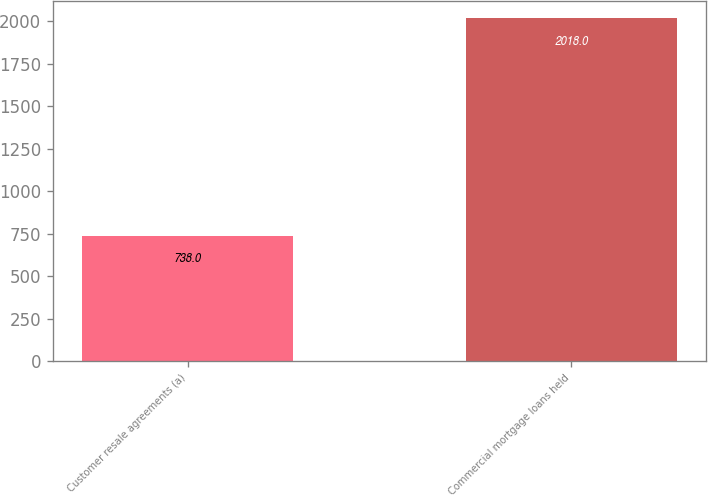<chart> <loc_0><loc_0><loc_500><loc_500><bar_chart><fcel>Customer resale agreements (a)<fcel>Commercial mortgage loans held<nl><fcel>738<fcel>2018<nl></chart> 